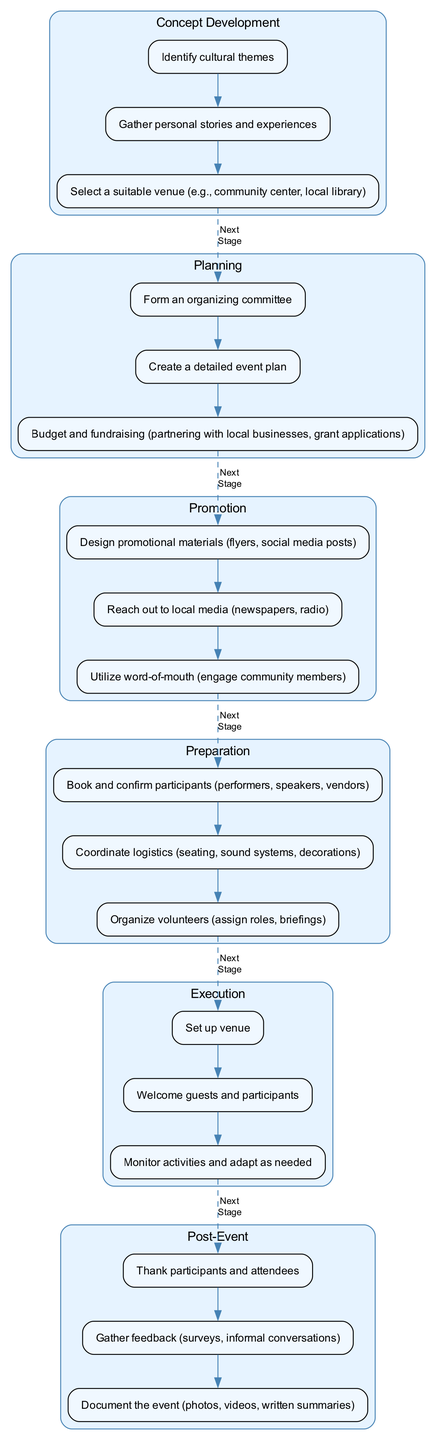What is the first stage of the event organization process? The first stage listed in the diagram is "Concept Development." This is found in the top part of the flow structure, indicating the beginning of the event planning process.
Answer: Concept Development How many tasks are included in the 'Planning' stage? The 'Planning' stage includes three tasks as shown in the diagram. By counting the listed tasks within that specific stage cluster, we confirm this number.
Answer: 3 What task comes after "Identify cultural themes"? Following the task "Identify cultural themes" in the "Concept Development" stage, the next task is "Gather personal stories and experiences." This is determined by the order of tasks listed within that stage.
Answer: Gather personal stories and experiences Which stage directly follows "Preparation"? The stage that follows "Preparation" in the flow chart is "Execution." This is understood by looking at the flow structure connecting each stage, noting the sequential progression.
Answer: Execution How many total stages are represented in the diagram? The diagram contains six distinct stages of the event organization process. This can be confirmed by counting each stage cluster shown vertically in the flow chart.
Answer: 6 What are the last tasks listed in the 'Post-Event' stage? The last two tasks in the 'Post-Event' stage are "Document the event (photos, videos, written summaries)." This is specifically noted as the final task when viewing the tasks in that cluster.
Answer: Document the event (photos, videos, written summaries) What type of relationship is represented between "Execution" and "Post-Event"? A dashed line connects "Execution" to "Post-Event," indicating a "Next Stage" relationship. This specific visual style signifies progression from one stage to the following stage.
Answer: Next Stage Which stage has the task of "Budget and fundraising"? The task "Budget and fundraising" is part of the "Planning" stage. This is identified by checking the tasks related to that specific stage in the hierarchy of the diagram.
Answer: Planning What is the purpose of the "Promotion" stage according to the diagram? The "Promotion" stage focuses on tasks aimed at promoting the event, such as designing promotional materials and reaching out to local media. This is derived from the tasks listed under that specific stage.
Answer: Promoting the event 